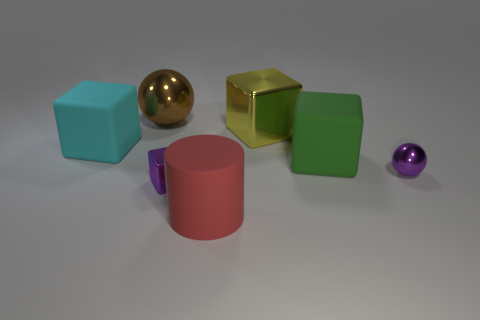Add 3 cyan things. How many objects exist? 10 Subtract all blocks. How many objects are left? 3 Add 5 shiny blocks. How many shiny blocks are left? 7 Add 4 big red cylinders. How many big red cylinders exist? 5 Subtract 0 gray cylinders. How many objects are left? 7 Subtract all small yellow objects. Subtract all large red cylinders. How many objects are left? 6 